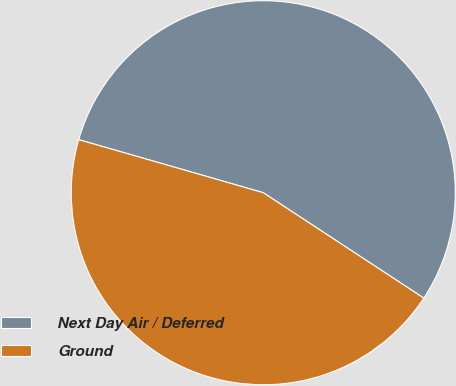Convert chart. <chart><loc_0><loc_0><loc_500><loc_500><pie_chart><fcel>Next Day Air / Deferred<fcel>Ground<nl><fcel>54.79%<fcel>45.21%<nl></chart> 